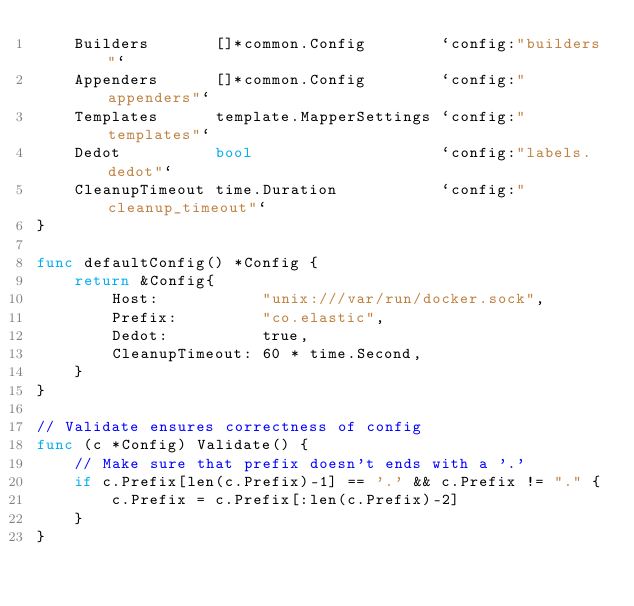<code> <loc_0><loc_0><loc_500><loc_500><_Go_>	Builders       []*common.Config        `config:"builders"`
	Appenders      []*common.Config        `config:"appenders"`
	Templates      template.MapperSettings `config:"templates"`
	Dedot          bool                    `config:"labels.dedot"`
	CleanupTimeout time.Duration           `config:"cleanup_timeout"`
}

func defaultConfig() *Config {
	return &Config{
		Host:           "unix:///var/run/docker.sock",
		Prefix:         "co.elastic",
		Dedot:          true,
		CleanupTimeout: 60 * time.Second,
	}
}

// Validate ensures correctness of config
func (c *Config) Validate() {
	// Make sure that prefix doesn't ends with a '.'
	if c.Prefix[len(c.Prefix)-1] == '.' && c.Prefix != "." {
		c.Prefix = c.Prefix[:len(c.Prefix)-2]
	}
}
</code> 